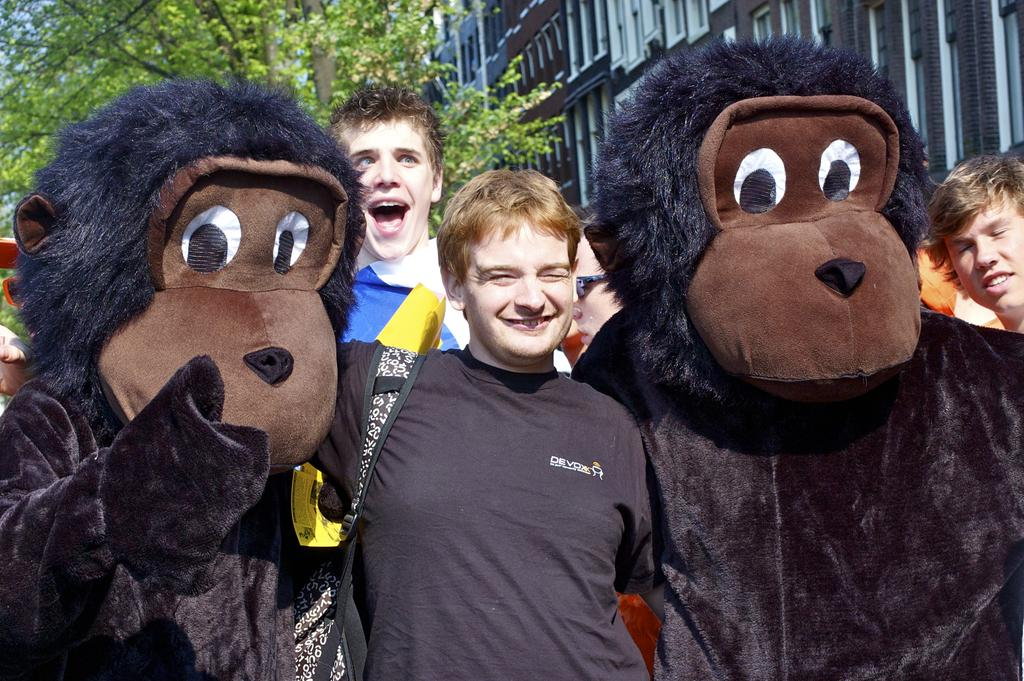Who or what can be seen in the image? There are people and mascots in the image. What is visible in the background of the image? There is a building and a tree in the background of the image. What type of insect is sitting on the mascot's head in the image? There are no insects present in the image; it only features people and mascots. 